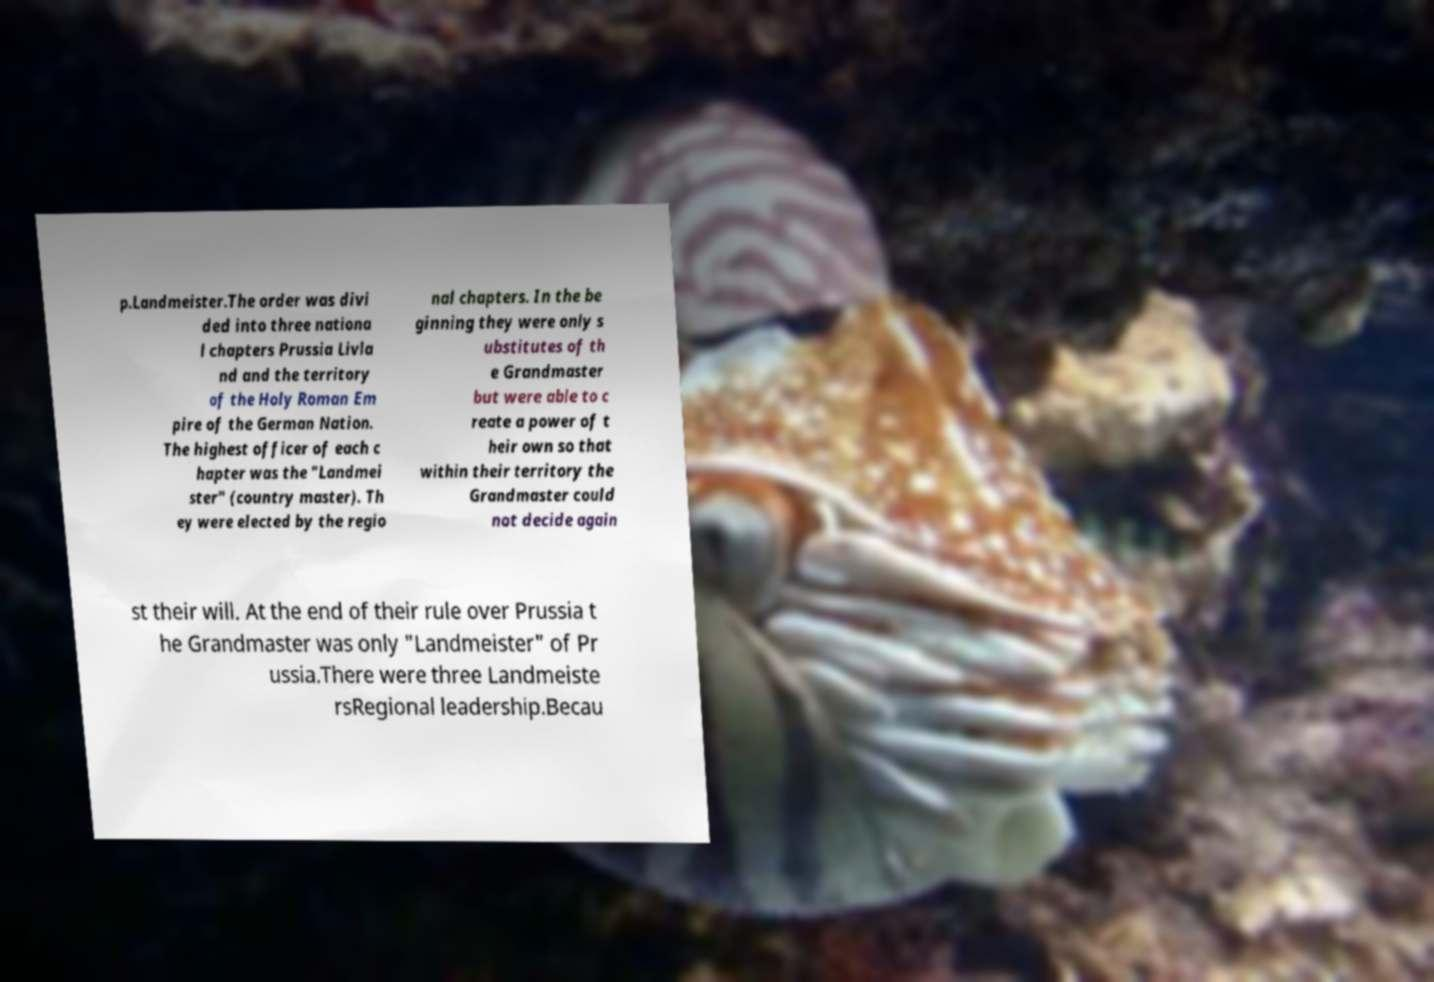Could you extract and type out the text from this image? p.Landmeister.The order was divi ded into three nationa l chapters Prussia Livla nd and the territory of the Holy Roman Em pire of the German Nation. The highest officer of each c hapter was the "Landmei ster" (country master). Th ey were elected by the regio nal chapters. In the be ginning they were only s ubstitutes of th e Grandmaster but were able to c reate a power of t heir own so that within their territory the Grandmaster could not decide again st their will. At the end of their rule over Prussia t he Grandmaster was only "Landmeister" of Pr ussia.There were three Landmeiste rsRegional leadership.Becau 